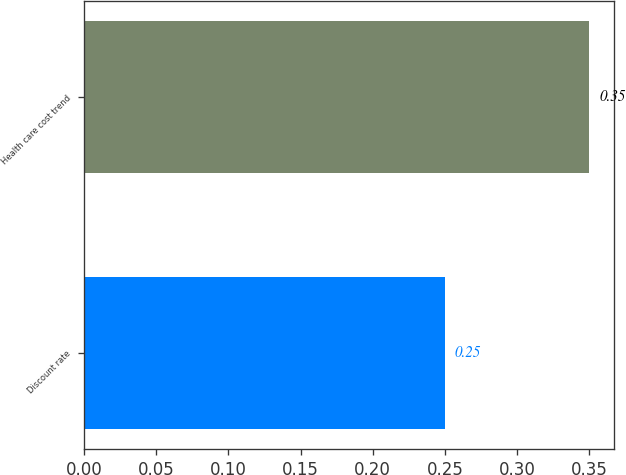<chart> <loc_0><loc_0><loc_500><loc_500><bar_chart><fcel>Discount rate<fcel>Health care cost trend<nl><fcel>0.25<fcel>0.35<nl></chart> 